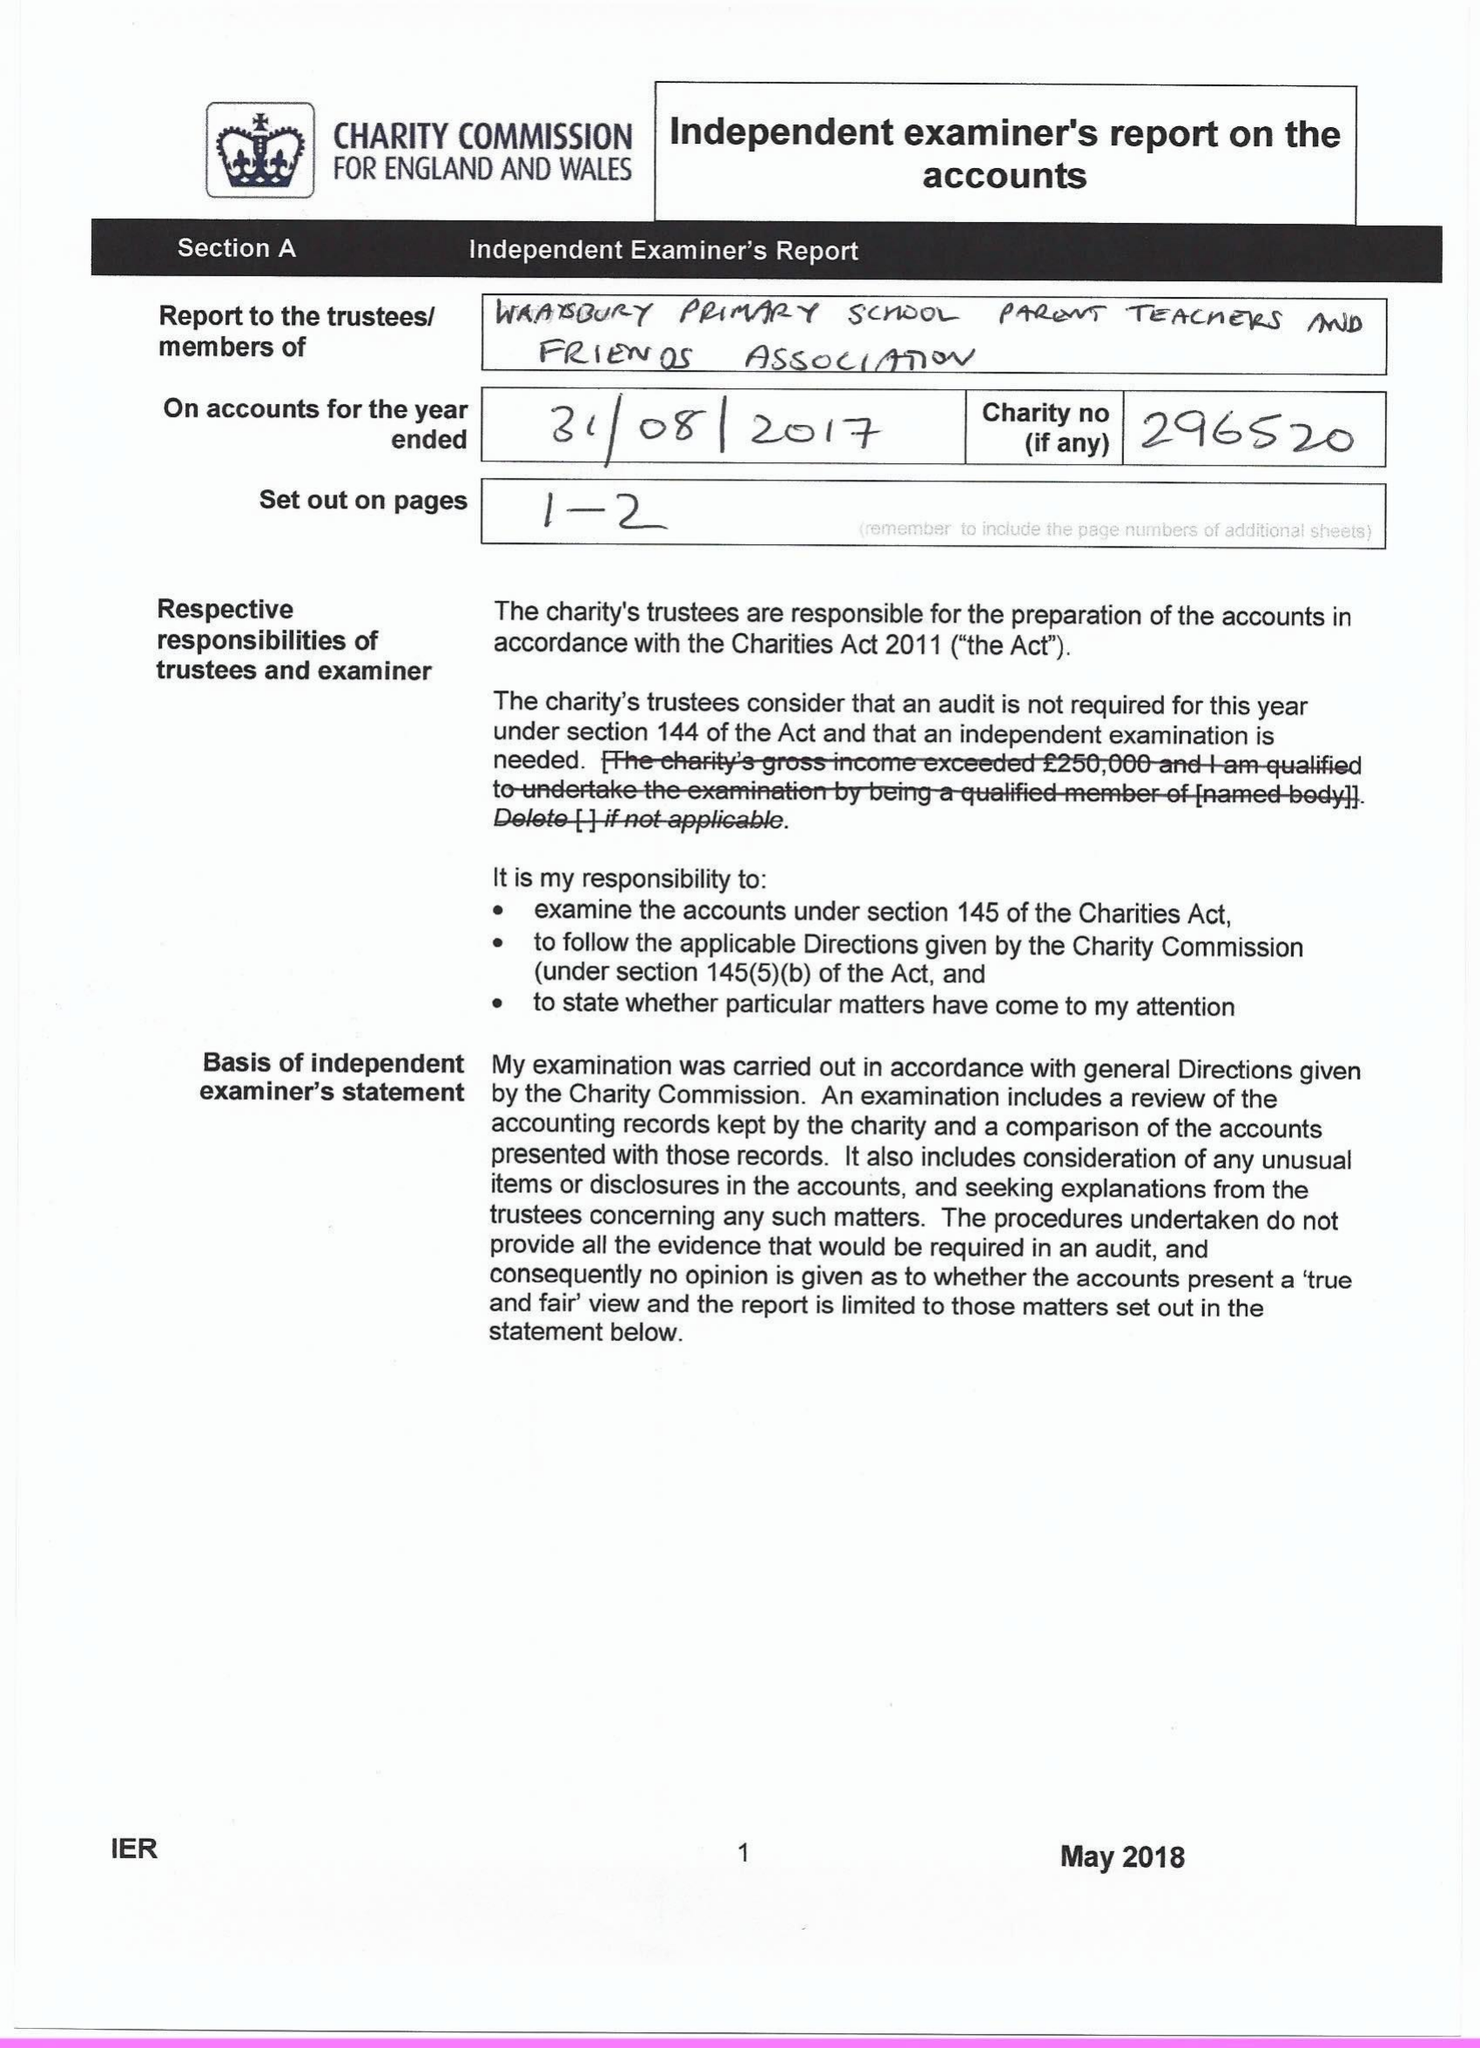What is the value for the spending_annually_in_british_pounds?
Answer the question using a single word or phrase. 19740.00 